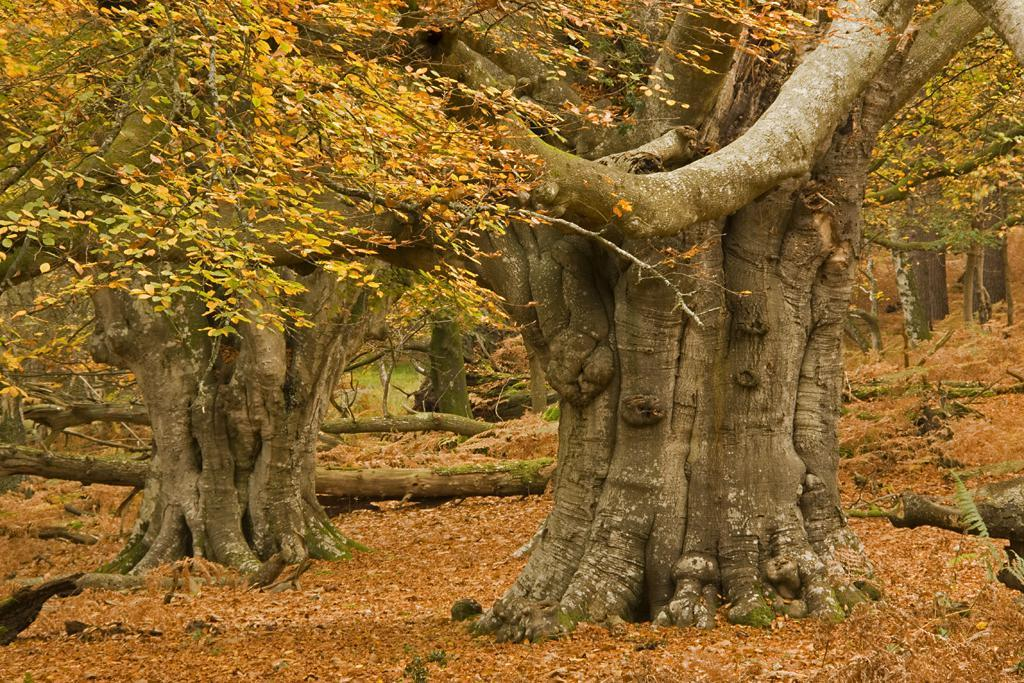What type of environment is depicted in the image? The image appears to depict a forest. What can be observed in the forest? There are many trees in the image. What is present on the ground in the image? Dry leaves are present on the ground in the image. What else can be seen on the trees in the image? There are a few tree trunks visible in the image. What type of stretch can be seen in the image? There is no stretch present in the image; it depicts a forest with trees and dry leaves on the ground. 